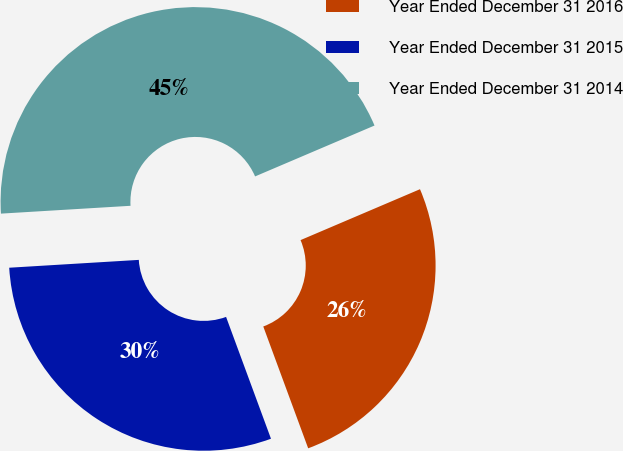<chart> <loc_0><loc_0><loc_500><loc_500><pie_chart><fcel>Year Ended December 31 2016<fcel>Year Ended December 31 2015<fcel>Year Ended December 31 2014<nl><fcel>25.79%<fcel>29.66%<fcel>44.55%<nl></chart> 